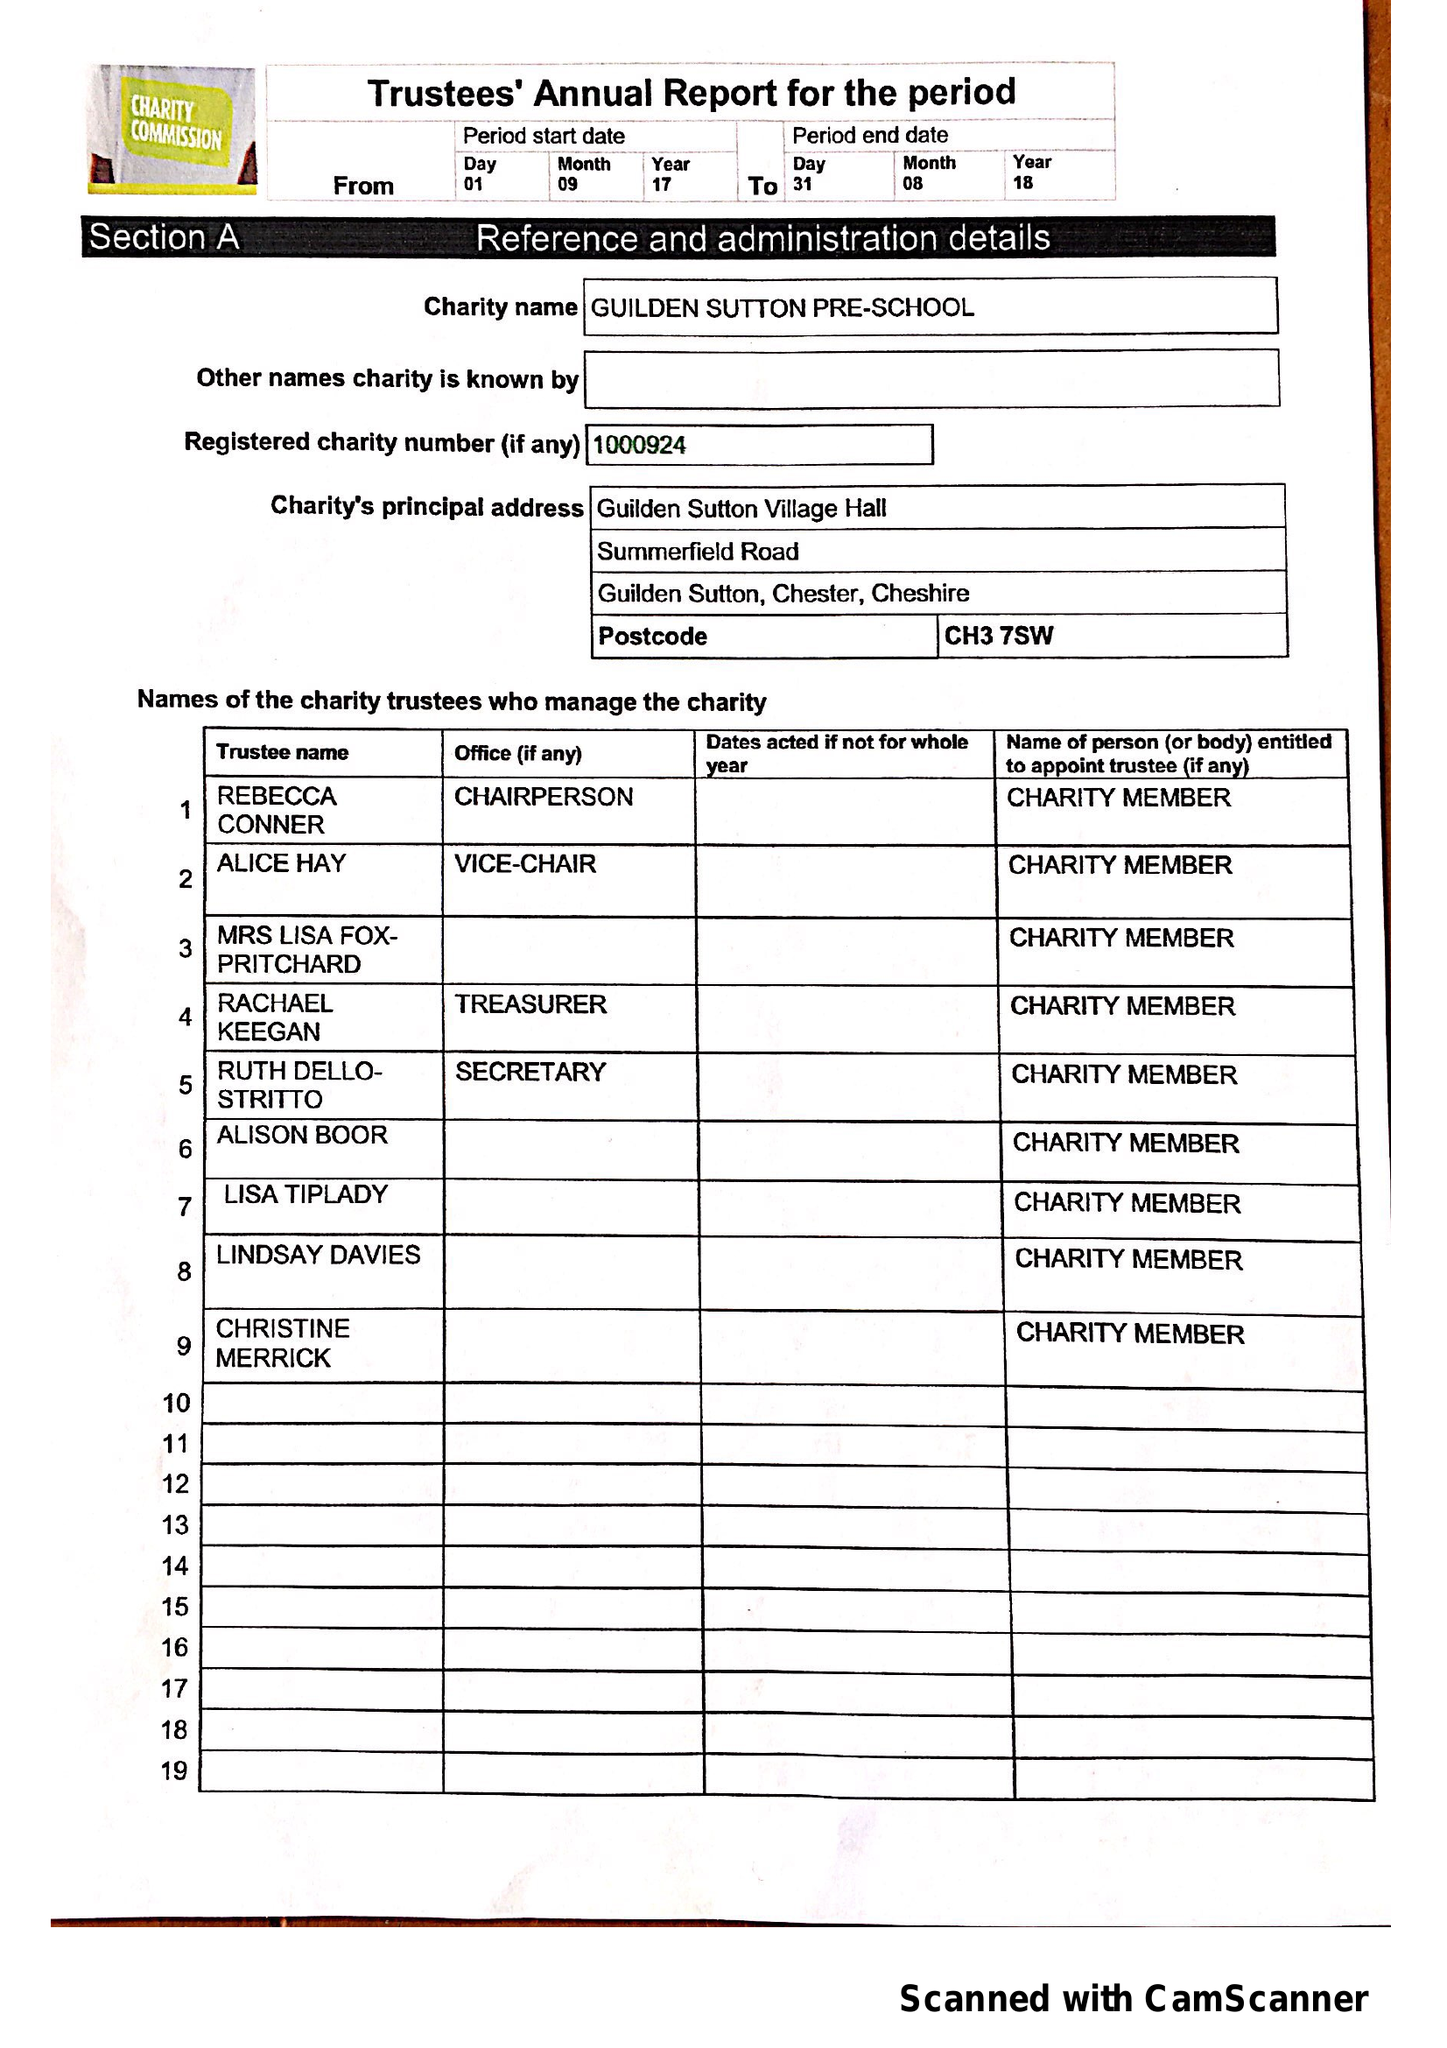What is the value for the address__street_line?
Answer the question using a single word or phrase. SUMMERFIELD ROAD 